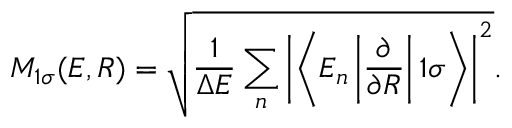<formula> <loc_0><loc_0><loc_500><loc_500>M _ { 1 \sigma } ( E , R ) = \sqrt { \frac { 1 } { \Delta E } \sum _ { n } \left | \left < E _ { n } \left | \frac { \partial } { \partial R } \right | 1 \sigma \right > \right | ^ { 2 } } .</formula> 